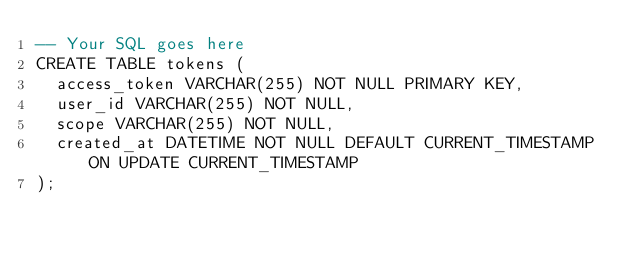Convert code to text. <code><loc_0><loc_0><loc_500><loc_500><_SQL_>-- Your SQL goes here
CREATE TABLE tokens (
  access_token VARCHAR(255) NOT NULL PRIMARY KEY,
  user_id VARCHAR(255) NOT NULL,
  scope VARCHAR(255) NOT NULL,
  created_at DATETIME NOT NULL DEFAULT CURRENT_TIMESTAMP ON UPDATE CURRENT_TIMESTAMP
);
</code> 